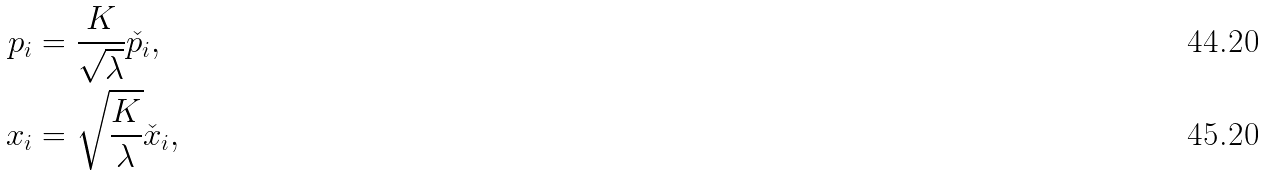Convert formula to latex. <formula><loc_0><loc_0><loc_500><loc_500>p _ { i } & = \frac { K } { \sqrt { \lambda } } \check { p } _ { i } , \\ x _ { i } & = \sqrt { \frac { K } { \lambda } } \check { x } _ { i } ,</formula> 